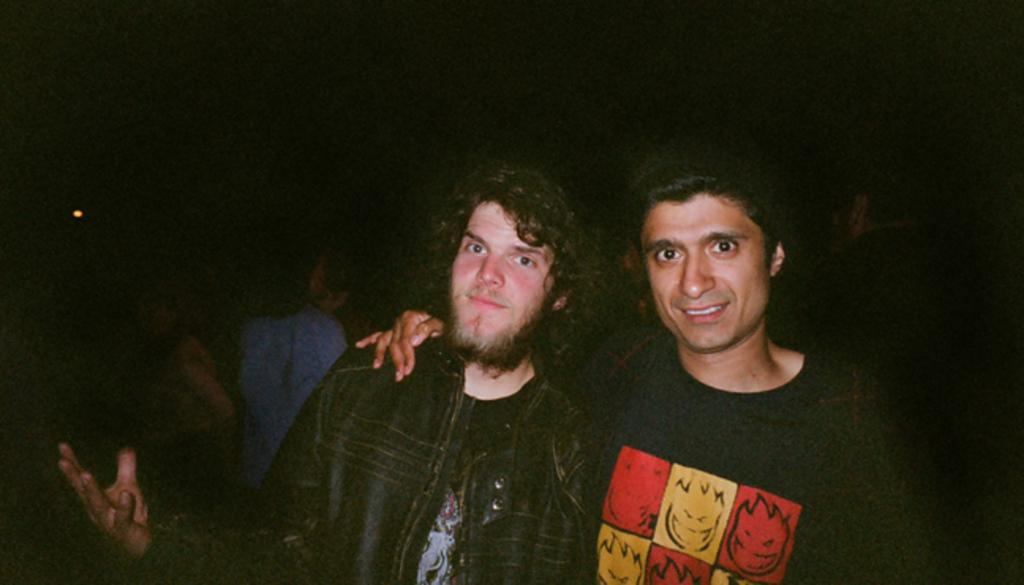How many people are in the image? There are two people in the center of the image, and other people are in the background area of the image. Can you describe the main subjects in the image? The main subjects are two people who are located in the center of the image. What is the approximate number of people visible in the background? It is difficult to determine an exact number, but there are other people visible in the background area of the image. What type of scissors are being used by the people in the image? There are no scissors present in the image. Are the two people in the center brothers? There is no information provided about the relationship between the two people in the image. What belief system do the people in the image follow? There is no information provided about the belief system of the people in the image. 